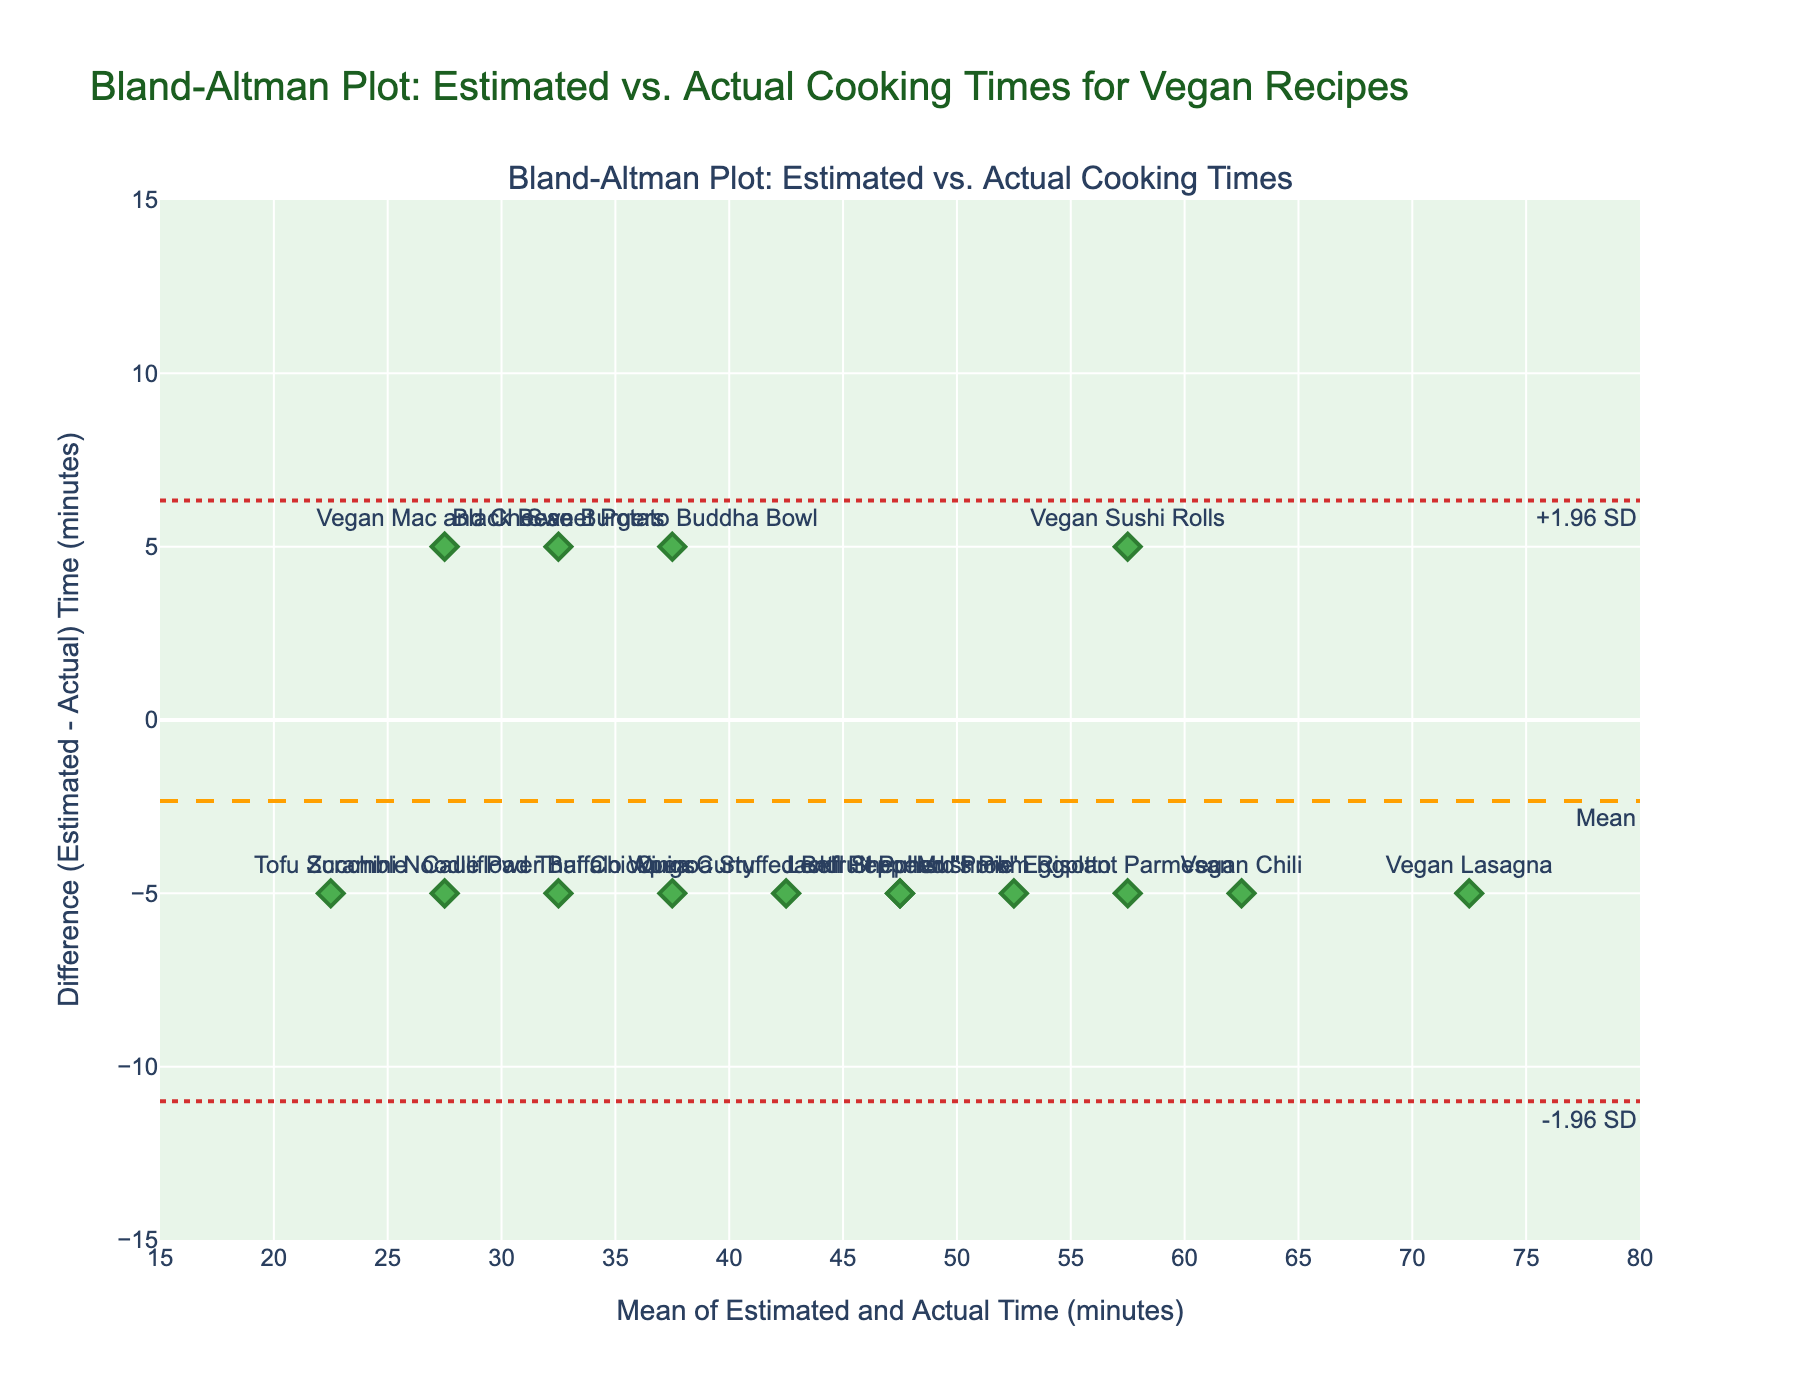What is the title of the plot? The title of the plot is displayed at the top and reads "Bland-Altman Plot: Estimated vs. Actual Cooking Times for Vegan Recipes." This title summarizes what the visualization represents.
Answer: Bland-Altman Plot: Estimated vs. Actual Cooking Times for Vegan Recipes How many recipes are represented in the plot? Each marker in the scatterplot represents a recipe, and there are 15 markers plotted, signifying 15 recipes.
Answer: 15 What is the mean difference in cooking times between the estimated and actual values? The mean difference is indicated by a dashed line labeled "Mean." Looking at the plot, this line is at 0 minutes.
Answer: 0 minutes What is the range of the x-axis for the mean of estimated and actual times? The x-axis range is displayed at the bottom of the plot and spans from 15 to 80 minutes.
Answer: 15 to 80 minutes Which recipe has the highest difference (estimated vs. actual) in cooking time? By observing the vertical distance of each marker from the 0 line, the "Vegan Mac and Cheese" has the largest negative difference at -5 minutes.
Answer: Vegan Mac and Cheese What are the limits of agreement in this plot? The limits of agreement are represented by the dotted lines labeled "+1.96 SD" and "-1.96 SD." These lines are at approximately 7 and -7 minutes respectively.
Answer: 7 and -7 minutes Are there any recipes where the estimated cooking time is exactly equal to the actual cooking time? A difference of 0 would mean the estimated and actual times are equal. Observing the plot, there is no marker exactly on the 0 line of the y-axis.
Answer: No What is the general trend shown in the plot regarding estimated vs. actual cooking times? Most of the points are clustered around the 0 line with a few deviations up and down, suggesting that the estimated times are generally close to the actual times with small variations.
Answer: Close estimates with small variations Is there a recipe where the actual cooking time is less than the estimated time by 5 minutes? Look for a marker placed at -5 on the y-axis. The "Vegan Mac and Cheese" is at this position.
Answer: Yes, Vegan Mac and Cheese On average, do the vegan recipes tend to have overestimated or underestimated cooking times? The mean difference is at 0, meaning there is no consistent tendency to either overestimate or underestimate the cooking times across recipes.
Answer: Neither 